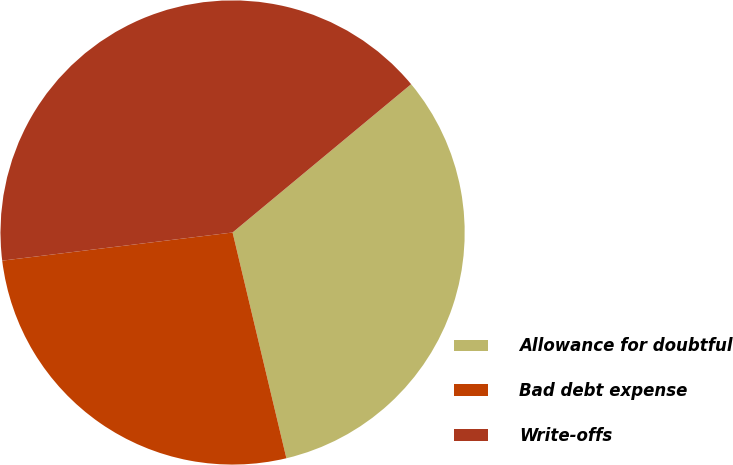Convert chart to OTSL. <chart><loc_0><loc_0><loc_500><loc_500><pie_chart><fcel>Allowance for doubtful<fcel>Bad debt expense<fcel>Write-offs<nl><fcel>32.31%<fcel>26.79%<fcel>40.91%<nl></chart> 